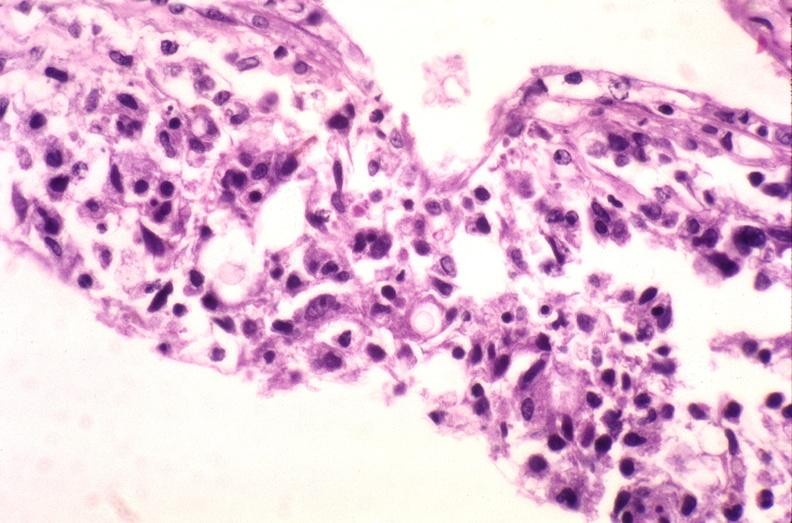what is present?
Answer the question using a single word or phrase. Nervous 